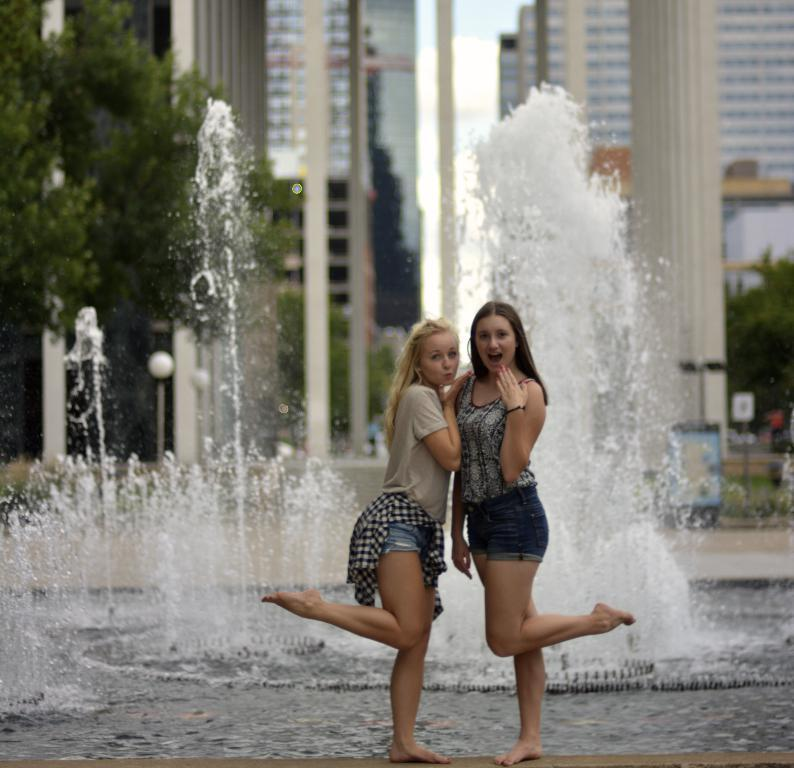What are the women in the image doing? The women in the front of the image are standing and posing. What is the main feature in the center of the image? There is a water fountain in the center of the image. What can be seen in the background of the image? There are trees and buildings in the background of the image. What else is present in the image? There are poles in the image. How many boats are visible in the image? There are no boats present in the image. What type of roof is covering the water fountain in the image? There is no roof covering the water fountain in the image; it is an open structure. 